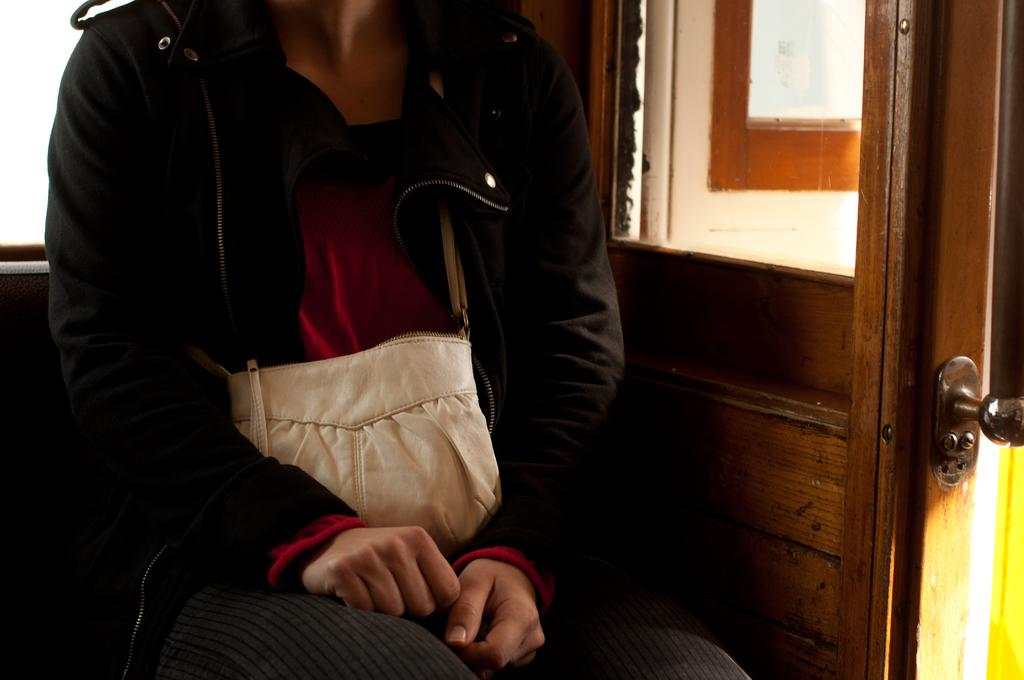What is the person in the image doing? There is a person sitting in the image. What is the person wearing that is visible in the image? The person is wearing a bag. What type of structure can be seen in the image? There is a door in the image. What object is made of glass in the image? There is a glass in the image. What type of bee can be seen buzzing around the person in the image? There is no bee present in the image; it only features a person sitting, a bag, a door, and a glass. 